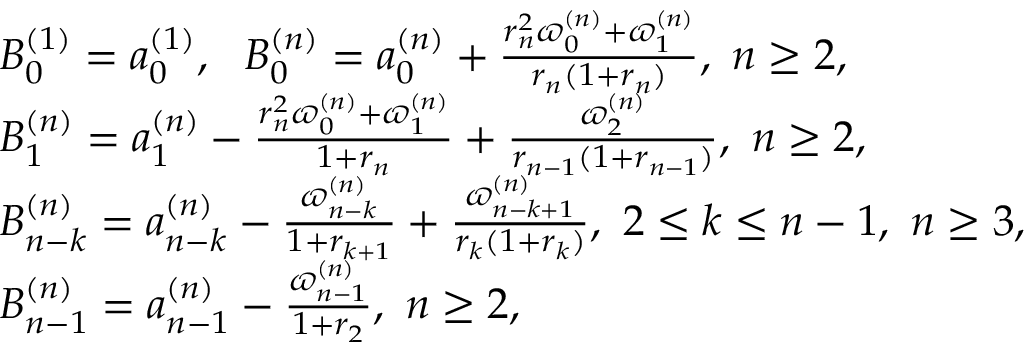<formula> <loc_0><loc_0><loc_500><loc_500>\begin{array} { r l } & { B _ { 0 } ^ { ( 1 ) } = a _ { 0 } ^ { ( 1 ) } , B _ { 0 } ^ { ( n ) } = a _ { 0 } ^ { ( n ) } + \frac { r _ { n } ^ { 2 } \varpi _ { 0 } ^ { ( n ) } + \varpi _ { 1 } ^ { ( n ) } } { r _ { n } ( 1 + r _ { n } ) } , n \geq 2 , } \\ & { B _ { 1 } ^ { ( n ) } = a _ { 1 } ^ { ( n ) } - \frac { r _ { n } ^ { 2 } \varpi _ { 0 } ^ { ( n ) } + \varpi _ { 1 } ^ { ( n ) } } { 1 + r _ { n } } + \frac { \varpi _ { 2 } ^ { ( n ) } } { r _ { n - 1 } ( 1 + r _ { n - 1 } ) } , n \geq 2 , } \\ & { B _ { n - k } ^ { ( n ) } = a _ { n - k } ^ { ( n ) } - \frac { \varpi _ { n - k } ^ { ( n ) } } { 1 + r _ { k + 1 } } + \frac { \varpi _ { n - k + 1 } ^ { ( n ) } } { r _ { k } ( 1 + r _ { k } ) } , 2 \leq k \leq n - 1 , n \geq 3 , } \\ & { B _ { n - 1 } ^ { ( n ) } = a _ { n - 1 } ^ { ( n ) } - \frac { \varpi _ { n - 1 } ^ { ( n ) } } { 1 + r _ { 2 } } , n \geq 2 , } \end{array}</formula> 